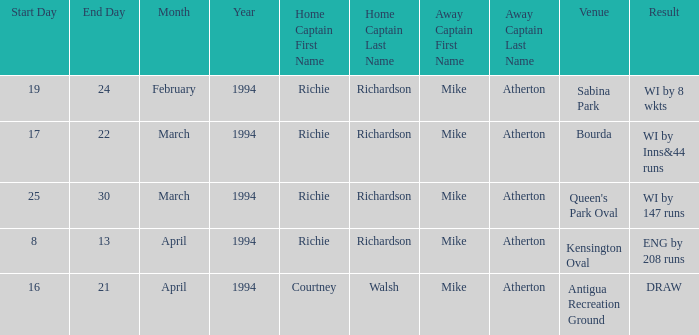Which Home captain has Date of 25,26,27,29,30 march 1994? Richie Richardson. 